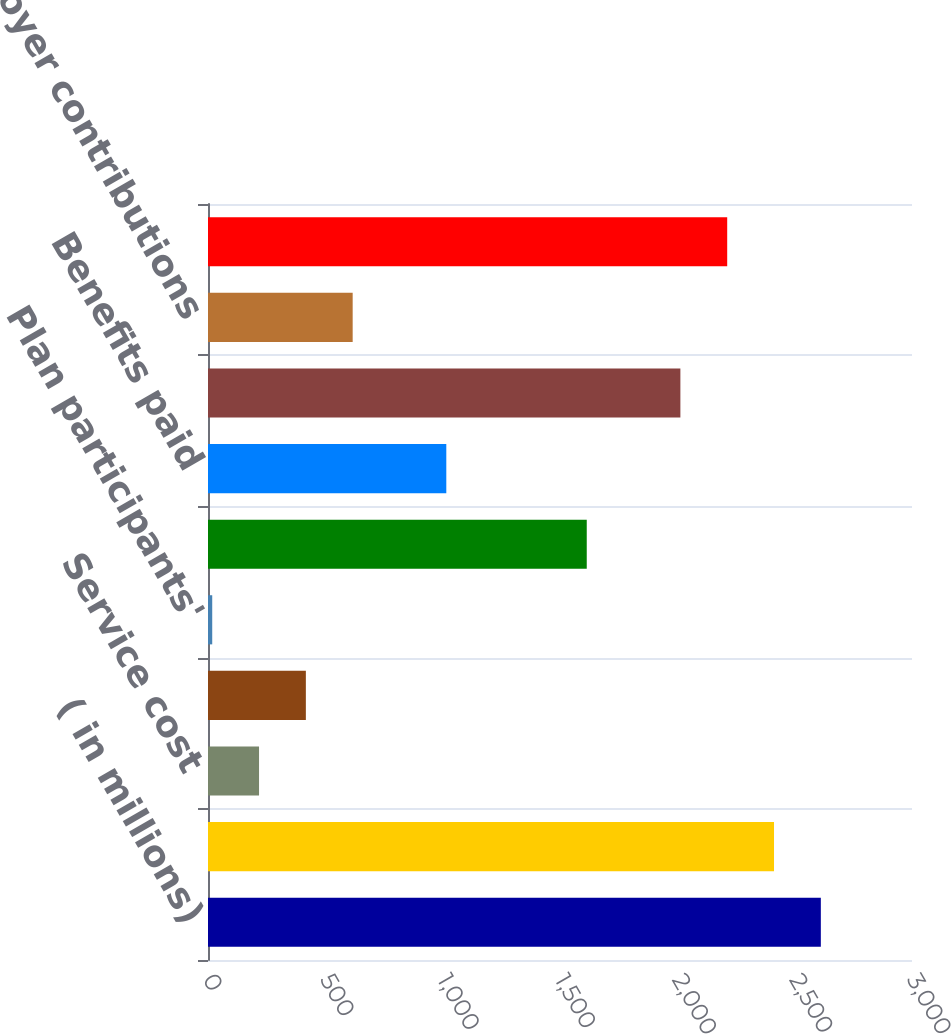Convert chart to OTSL. <chart><loc_0><loc_0><loc_500><loc_500><bar_chart><fcel>( in millions)<fcel>Benefit obligation at<fcel>Service cost<fcel>Interest cost<fcel>Plan participants'<fcel>Actuarial loss (gain)<fcel>Benefits paid<fcel>Benefit obligation at end of<fcel>Employer contributions<fcel>Funded status<nl><fcel>2611.5<fcel>2412<fcel>217.5<fcel>417<fcel>18<fcel>1614<fcel>1015.5<fcel>2013<fcel>616.5<fcel>2212.5<nl></chart> 